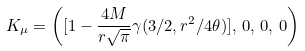Convert formula to latex. <formula><loc_0><loc_0><loc_500><loc_500>K _ { \mu } = \left ( [ 1 - \frac { 4 M } { r \sqrt { \pi } } \gamma ( 3 / 2 , r ^ { 2 } / 4 \theta ) ] , \, 0 , \, 0 , \, 0 \right )</formula> 